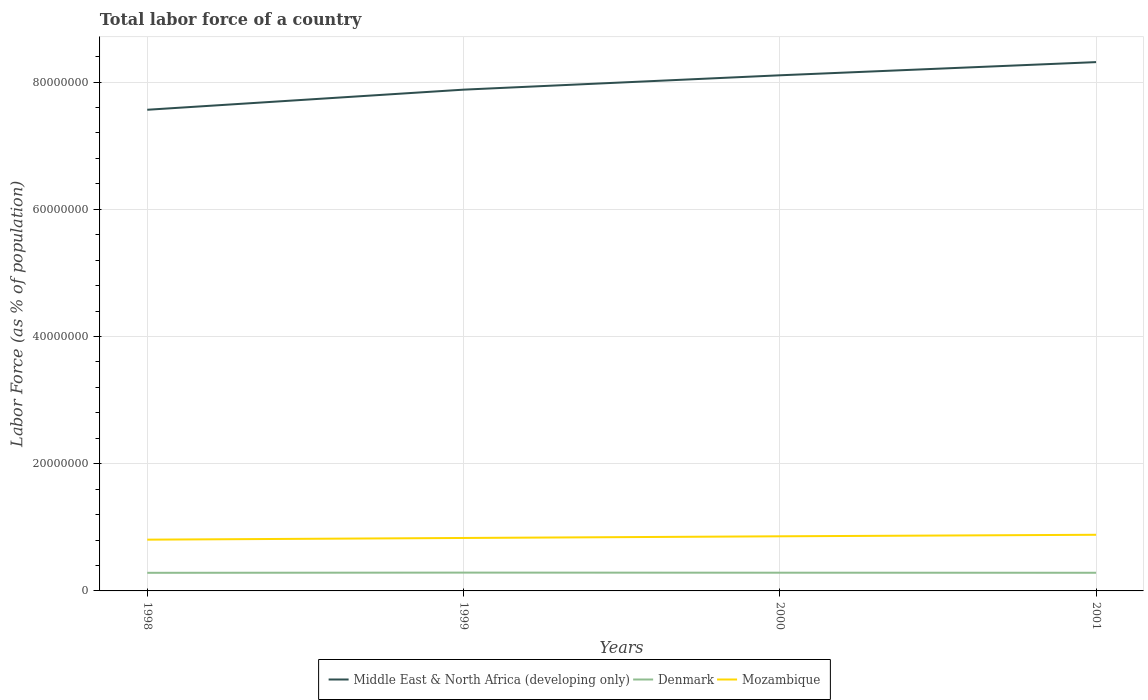How many different coloured lines are there?
Offer a terse response. 3. Does the line corresponding to Middle East & North Africa (developing only) intersect with the line corresponding to Denmark?
Your response must be concise. No. Is the number of lines equal to the number of legend labels?
Your answer should be compact. Yes. Across all years, what is the maximum percentage of labor force in Denmark?
Provide a succinct answer. 2.85e+06. What is the total percentage of labor force in Denmark in the graph?
Ensure brevity in your answer.  1.50e+04. What is the difference between the highest and the second highest percentage of labor force in Middle East & North Africa (developing only)?
Ensure brevity in your answer.  7.49e+06. What is the difference between the highest and the lowest percentage of labor force in Middle East & North Africa (developing only)?
Your answer should be compact. 2. How many years are there in the graph?
Your answer should be very brief. 4. What is the difference between two consecutive major ticks on the Y-axis?
Give a very brief answer. 2.00e+07. Are the values on the major ticks of Y-axis written in scientific E-notation?
Offer a very short reply. No. Where does the legend appear in the graph?
Offer a terse response. Bottom center. How many legend labels are there?
Your response must be concise. 3. How are the legend labels stacked?
Your answer should be very brief. Horizontal. What is the title of the graph?
Your response must be concise. Total labor force of a country. Does "Antigua and Barbuda" appear as one of the legend labels in the graph?
Ensure brevity in your answer.  No. What is the label or title of the Y-axis?
Ensure brevity in your answer.  Labor Force (as % of population). What is the Labor Force (as % of population) of Middle East & North Africa (developing only) in 1998?
Your answer should be compact. 7.56e+07. What is the Labor Force (as % of population) of Denmark in 1998?
Give a very brief answer. 2.85e+06. What is the Labor Force (as % of population) of Mozambique in 1998?
Provide a succinct answer. 8.06e+06. What is the Labor Force (as % of population) of Middle East & North Africa (developing only) in 1999?
Your response must be concise. 7.88e+07. What is the Labor Force (as % of population) of Denmark in 1999?
Offer a very short reply. 2.88e+06. What is the Labor Force (as % of population) of Mozambique in 1999?
Keep it short and to the point. 8.33e+06. What is the Labor Force (as % of population) of Middle East & North Africa (developing only) in 2000?
Your response must be concise. 8.11e+07. What is the Labor Force (as % of population) in Denmark in 2000?
Give a very brief answer. 2.86e+06. What is the Labor Force (as % of population) in Mozambique in 2000?
Offer a terse response. 8.59e+06. What is the Labor Force (as % of population) in Middle East & North Africa (developing only) in 2001?
Provide a short and direct response. 8.31e+07. What is the Labor Force (as % of population) in Denmark in 2001?
Keep it short and to the point. 2.85e+06. What is the Labor Force (as % of population) in Mozambique in 2001?
Provide a short and direct response. 8.83e+06. Across all years, what is the maximum Labor Force (as % of population) in Middle East & North Africa (developing only)?
Provide a succinct answer. 8.31e+07. Across all years, what is the maximum Labor Force (as % of population) in Denmark?
Your answer should be very brief. 2.88e+06. Across all years, what is the maximum Labor Force (as % of population) of Mozambique?
Your answer should be compact. 8.83e+06. Across all years, what is the minimum Labor Force (as % of population) of Middle East & North Africa (developing only)?
Your answer should be very brief. 7.56e+07. Across all years, what is the minimum Labor Force (as % of population) in Denmark?
Your response must be concise. 2.85e+06. Across all years, what is the minimum Labor Force (as % of population) in Mozambique?
Your answer should be very brief. 8.06e+06. What is the total Labor Force (as % of population) in Middle East & North Africa (developing only) in the graph?
Your answer should be compact. 3.19e+08. What is the total Labor Force (as % of population) of Denmark in the graph?
Provide a short and direct response. 1.14e+07. What is the total Labor Force (as % of population) in Mozambique in the graph?
Your answer should be very brief. 3.38e+07. What is the difference between the Labor Force (as % of population) in Middle East & North Africa (developing only) in 1998 and that in 1999?
Provide a short and direct response. -3.16e+06. What is the difference between the Labor Force (as % of population) of Denmark in 1998 and that in 1999?
Give a very brief answer. -3.20e+04. What is the difference between the Labor Force (as % of population) in Mozambique in 1998 and that in 1999?
Keep it short and to the point. -2.66e+05. What is the difference between the Labor Force (as % of population) of Middle East & North Africa (developing only) in 1998 and that in 2000?
Make the answer very short. -5.42e+06. What is the difference between the Labor Force (as % of population) of Denmark in 1998 and that in 2000?
Offer a very short reply. -1.71e+04. What is the difference between the Labor Force (as % of population) in Mozambique in 1998 and that in 2000?
Your answer should be very brief. -5.28e+05. What is the difference between the Labor Force (as % of population) of Middle East & North Africa (developing only) in 1998 and that in 2001?
Make the answer very short. -7.49e+06. What is the difference between the Labor Force (as % of population) in Denmark in 1998 and that in 2001?
Give a very brief answer. -6680. What is the difference between the Labor Force (as % of population) in Mozambique in 1998 and that in 2001?
Offer a very short reply. -7.67e+05. What is the difference between the Labor Force (as % of population) in Middle East & North Africa (developing only) in 1999 and that in 2000?
Offer a very short reply. -2.26e+06. What is the difference between the Labor Force (as % of population) in Denmark in 1999 and that in 2000?
Keep it short and to the point. 1.50e+04. What is the difference between the Labor Force (as % of population) in Mozambique in 1999 and that in 2000?
Your answer should be compact. -2.62e+05. What is the difference between the Labor Force (as % of population) of Middle East & North Africa (developing only) in 1999 and that in 2001?
Make the answer very short. -4.33e+06. What is the difference between the Labor Force (as % of population) in Denmark in 1999 and that in 2001?
Offer a very short reply. 2.53e+04. What is the difference between the Labor Force (as % of population) in Mozambique in 1999 and that in 2001?
Provide a short and direct response. -5.01e+05. What is the difference between the Labor Force (as % of population) of Middle East & North Africa (developing only) in 2000 and that in 2001?
Your response must be concise. -2.07e+06. What is the difference between the Labor Force (as % of population) in Denmark in 2000 and that in 2001?
Keep it short and to the point. 1.04e+04. What is the difference between the Labor Force (as % of population) of Mozambique in 2000 and that in 2001?
Give a very brief answer. -2.39e+05. What is the difference between the Labor Force (as % of population) of Middle East & North Africa (developing only) in 1998 and the Labor Force (as % of population) of Denmark in 1999?
Make the answer very short. 7.28e+07. What is the difference between the Labor Force (as % of population) in Middle East & North Africa (developing only) in 1998 and the Labor Force (as % of population) in Mozambique in 1999?
Your response must be concise. 6.73e+07. What is the difference between the Labor Force (as % of population) of Denmark in 1998 and the Labor Force (as % of population) of Mozambique in 1999?
Keep it short and to the point. -5.48e+06. What is the difference between the Labor Force (as % of population) in Middle East & North Africa (developing only) in 1998 and the Labor Force (as % of population) in Denmark in 2000?
Ensure brevity in your answer.  7.28e+07. What is the difference between the Labor Force (as % of population) in Middle East & North Africa (developing only) in 1998 and the Labor Force (as % of population) in Mozambique in 2000?
Offer a very short reply. 6.71e+07. What is the difference between the Labor Force (as % of population) of Denmark in 1998 and the Labor Force (as % of population) of Mozambique in 2000?
Keep it short and to the point. -5.74e+06. What is the difference between the Labor Force (as % of population) of Middle East & North Africa (developing only) in 1998 and the Labor Force (as % of population) of Denmark in 2001?
Ensure brevity in your answer.  7.28e+07. What is the difference between the Labor Force (as % of population) of Middle East & North Africa (developing only) in 1998 and the Labor Force (as % of population) of Mozambique in 2001?
Your response must be concise. 6.68e+07. What is the difference between the Labor Force (as % of population) in Denmark in 1998 and the Labor Force (as % of population) in Mozambique in 2001?
Provide a short and direct response. -5.98e+06. What is the difference between the Labor Force (as % of population) of Middle East & North Africa (developing only) in 1999 and the Labor Force (as % of population) of Denmark in 2000?
Offer a very short reply. 7.59e+07. What is the difference between the Labor Force (as % of population) of Middle East & North Africa (developing only) in 1999 and the Labor Force (as % of population) of Mozambique in 2000?
Offer a very short reply. 7.02e+07. What is the difference between the Labor Force (as % of population) of Denmark in 1999 and the Labor Force (as % of population) of Mozambique in 2000?
Provide a short and direct response. -5.71e+06. What is the difference between the Labor Force (as % of population) of Middle East & North Africa (developing only) in 1999 and the Labor Force (as % of population) of Denmark in 2001?
Provide a short and direct response. 7.60e+07. What is the difference between the Labor Force (as % of population) of Middle East & North Africa (developing only) in 1999 and the Labor Force (as % of population) of Mozambique in 2001?
Keep it short and to the point. 7.00e+07. What is the difference between the Labor Force (as % of population) of Denmark in 1999 and the Labor Force (as % of population) of Mozambique in 2001?
Give a very brief answer. -5.95e+06. What is the difference between the Labor Force (as % of population) of Middle East & North Africa (developing only) in 2000 and the Labor Force (as % of population) of Denmark in 2001?
Provide a succinct answer. 7.82e+07. What is the difference between the Labor Force (as % of population) of Middle East & North Africa (developing only) in 2000 and the Labor Force (as % of population) of Mozambique in 2001?
Offer a terse response. 7.22e+07. What is the difference between the Labor Force (as % of population) of Denmark in 2000 and the Labor Force (as % of population) of Mozambique in 2001?
Ensure brevity in your answer.  -5.96e+06. What is the average Labor Force (as % of population) of Middle East & North Africa (developing only) per year?
Offer a terse response. 7.97e+07. What is the average Labor Force (as % of population) of Denmark per year?
Offer a very short reply. 2.86e+06. What is the average Labor Force (as % of population) in Mozambique per year?
Provide a short and direct response. 8.45e+06. In the year 1998, what is the difference between the Labor Force (as % of population) of Middle East & North Africa (developing only) and Labor Force (as % of population) of Denmark?
Keep it short and to the point. 7.28e+07. In the year 1998, what is the difference between the Labor Force (as % of population) in Middle East & North Africa (developing only) and Labor Force (as % of population) in Mozambique?
Keep it short and to the point. 6.76e+07. In the year 1998, what is the difference between the Labor Force (as % of population) in Denmark and Labor Force (as % of population) in Mozambique?
Offer a terse response. -5.21e+06. In the year 1999, what is the difference between the Labor Force (as % of population) of Middle East & North Africa (developing only) and Labor Force (as % of population) of Denmark?
Ensure brevity in your answer.  7.59e+07. In the year 1999, what is the difference between the Labor Force (as % of population) of Middle East & North Africa (developing only) and Labor Force (as % of population) of Mozambique?
Offer a very short reply. 7.05e+07. In the year 1999, what is the difference between the Labor Force (as % of population) in Denmark and Labor Force (as % of population) in Mozambique?
Offer a very short reply. -5.45e+06. In the year 2000, what is the difference between the Labor Force (as % of population) in Middle East & North Africa (developing only) and Labor Force (as % of population) in Denmark?
Provide a succinct answer. 7.82e+07. In the year 2000, what is the difference between the Labor Force (as % of population) of Middle East & North Africa (developing only) and Labor Force (as % of population) of Mozambique?
Offer a terse response. 7.25e+07. In the year 2000, what is the difference between the Labor Force (as % of population) of Denmark and Labor Force (as % of population) of Mozambique?
Your answer should be very brief. -5.72e+06. In the year 2001, what is the difference between the Labor Force (as % of population) in Middle East & North Africa (developing only) and Labor Force (as % of population) in Denmark?
Ensure brevity in your answer.  8.03e+07. In the year 2001, what is the difference between the Labor Force (as % of population) in Middle East & North Africa (developing only) and Labor Force (as % of population) in Mozambique?
Make the answer very short. 7.43e+07. In the year 2001, what is the difference between the Labor Force (as % of population) of Denmark and Labor Force (as % of population) of Mozambique?
Your answer should be compact. -5.97e+06. What is the ratio of the Labor Force (as % of population) in Middle East & North Africa (developing only) in 1998 to that in 1999?
Keep it short and to the point. 0.96. What is the ratio of the Labor Force (as % of population) of Denmark in 1998 to that in 1999?
Keep it short and to the point. 0.99. What is the ratio of the Labor Force (as % of population) of Mozambique in 1998 to that in 1999?
Ensure brevity in your answer.  0.97. What is the ratio of the Labor Force (as % of population) of Middle East & North Africa (developing only) in 1998 to that in 2000?
Give a very brief answer. 0.93. What is the ratio of the Labor Force (as % of population) of Denmark in 1998 to that in 2000?
Your response must be concise. 0.99. What is the ratio of the Labor Force (as % of population) of Mozambique in 1998 to that in 2000?
Your answer should be very brief. 0.94. What is the ratio of the Labor Force (as % of population) of Middle East & North Africa (developing only) in 1998 to that in 2001?
Keep it short and to the point. 0.91. What is the ratio of the Labor Force (as % of population) in Denmark in 1998 to that in 2001?
Ensure brevity in your answer.  1. What is the ratio of the Labor Force (as % of population) of Mozambique in 1998 to that in 2001?
Give a very brief answer. 0.91. What is the ratio of the Labor Force (as % of population) in Middle East & North Africa (developing only) in 1999 to that in 2000?
Provide a succinct answer. 0.97. What is the ratio of the Labor Force (as % of population) of Denmark in 1999 to that in 2000?
Give a very brief answer. 1.01. What is the ratio of the Labor Force (as % of population) of Mozambique in 1999 to that in 2000?
Offer a terse response. 0.97. What is the ratio of the Labor Force (as % of population) of Middle East & North Africa (developing only) in 1999 to that in 2001?
Keep it short and to the point. 0.95. What is the ratio of the Labor Force (as % of population) in Denmark in 1999 to that in 2001?
Make the answer very short. 1.01. What is the ratio of the Labor Force (as % of population) in Mozambique in 1999 to that in 2001?
Give a very brief answer. 0.94. What is the ratio of the Labor Force (as % of population) of Middle East & North Africa (developing only) in 2000 to that in 2001?
Provide a short and direct response. 0.98. What is the ratio of the Labor Force (as % of population) in Mozambique in 2000 to that in 2001?
Offer a terse response. 0.97. What is the difference between the highest and the second highest Labor Force (as % of population) in Middle East & North Africa (developing only)?
Your response must be concise. 2.07e+06. What is the difference between the highest and the second highest Labor Force (as % of population) in Denmark?
Your answer should be very brief. 1.50e+04. What is the difference between the highest and the second highest Labor Force (as % of population) of Mozambique?
Your answer should be compact. 2.39e+05. What is the difference between the highest and the lowest Labor Force (as % of population) in Middle East & North Africa (developing only)?
Ensure brevity in your answer.  7.49e+06. What is the difference between the highest and the lowest Labor Force (as % of population) in Denmark?
Provide a short and direct response. 3.20e+04. What is the difference between the highest and the lowest Labor Force (as % of population) in Mozambique?
Provide a short and direct response. 7.67e+05. 